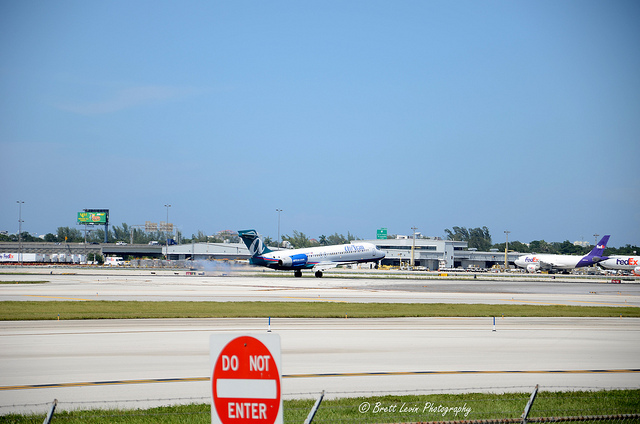Based on this image, what can you infer about the airport's location? While the image does not provide explicit details about the geographic location of the airport, the presence of multiple large aircraft, such as the ones from FedEx and the visible airline with a blue and white fuselage, suggests that this is a major airport likely situated near a large city or industrial area. Additionally, the lush green landscape and absence of snow or desert-like features might indicate a temperate climate zone. Are there any indications of airport traffic or congestion? The image shows multiple airplanes on the ground, both in the foreground and the background, which implies a typical level of activity for a commercial airport. There is no clear evidence of congestion, such as stacked planes waiting to take off or land, but the presence of these planes indicates ongoing airport operations. 